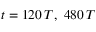<formula> <loc_0><loc_0><loc_500><loc_500>t = 1 2 0 \, T , 4 8 0 \, T</formula> 